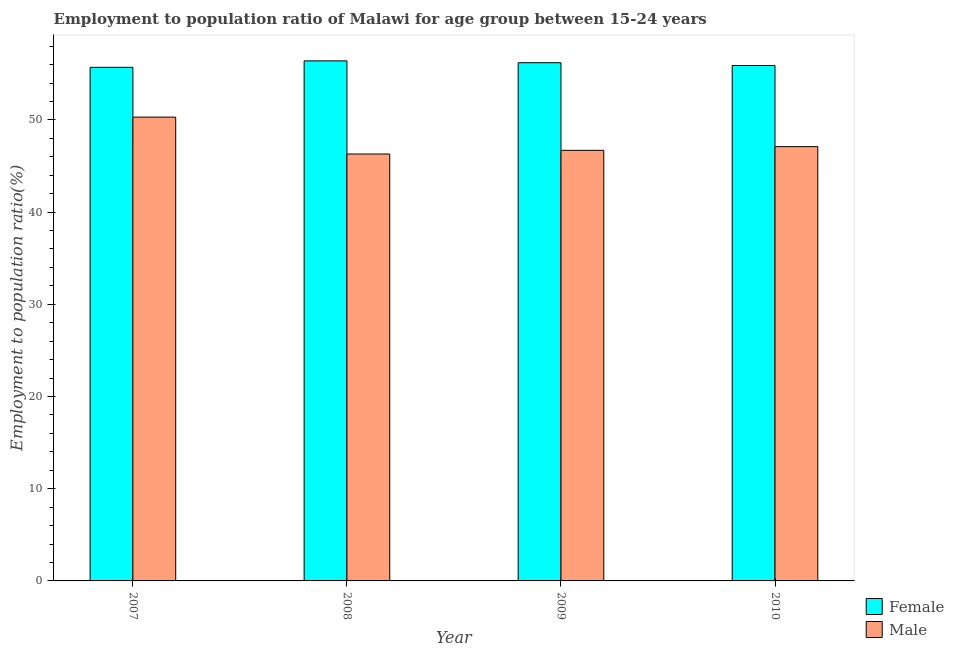How many groups of bars are there?
Provide a succinct answer. 4. Are the number of bars on each tick of the X-axis equal?
Give a very brief answer. Yes. How many bars are there on the 3rd tick from the right?
Offer a very short reply. 2. What is the employment to population ratio(male) in 2009?
Make the answer very short. 46.7. Across all years, what is the maximum employment to population ratio(female)?
Provide a short and direct response. 56.4. Across all years, what is the minimum employment to population ratio(male)?
Make the answer very short. 46.3. In which year was the employment to population ratio(male) maximum?
Offer a very short reply. 2007. What is the total employment to population ratio(female) in the graph?
Make the answer very short. 224.2. What is the difference between the employment to population ratio(male) in 2009 and that in 2010?
Your answer should be compact. -0.4. What is the difference between the employment to population ratio(male) in 2010 and the employment to population ratio(female) in 2007?
Offer a very short reply. -3.2. What is the average employment to population ratio(female) per year?
Your response must be concise. 56.05. In the year 2008, what is the difference between the employment to population ratio(female) and employment to population ratio(male)?
Your answer should be very brief. 0. In how many years, is the employment to population ratio(female) greater than 14 %?
Provide a short and direct response. 4. What is the ratio of the employment to population ratio(male) in 2007 to that in 2009?
Offer a terse response. 1.08. Is the employment to population ratio(male) in 2008 less than that in 2009?
Offer a very short reply. Yes. What is the difference between the highest and the second highest employment to population ratio(male)?
Offer a very short reply. 3.2. What is the difference between the highest and the lowest employment to population ratio(male)?
Give a very brief answer. 4. In how many years, is the employment to population ratio(male) greater than the average employment to population ratio(male) taken over all years?
Keep it short and to the point. 1. What does the 2nd bar from the left in 2009 represents?
Provide a succinct answer. Male. What does the 1st bar from the right in 2007 represents?
Provide a succinct answer. Male. Does the graph contain grids?
Your answer should be compact. No. What is the title of the graph?
Your answer should be compact. Employment to population ratio of Malawi for age group between 15-24 years. What is the label or title of the Y-axis?
Give a very brief answer. Employment to population ratio(%). What is the Employment to population ratio(%) of Female in 2007?
Offer a terse response. 55.7. What is the Employment to population ratio(%) in Male in 2007?
Offer a very short reply. 50.3. What is the Employment to population ratio(%) in Female in 2008?
Give a very brief answer. 56.4. What is the Employment to population ratio(%) of Male in 2008?
Give a very brief answer. 46.3. What is the Employment to population ratio(%) in Female in 2009?
Provide a short and direct response. 56.2. What is the Employment to population ratio(%) in Male in 2009?
Keep it short and to the point. 46.7. What is the Employment to population ratio(%) of Female in 2010?
Your answer should be very brief. 55.9. What is the Employment to population ratio(%) of Male in 2010?
Make the answer very short. 47.1. Across all years, what is the maximum Employment to population ratio(%) in Female?
Provide a succinct answer. 56.4. Across all years, what is the maximum Employment to population ratio(%) in Male?
Your answer should be compact. 50.3. Across all years, what is the minimum Employment to population ratio(%) in Female?
Offer a terse response. 55.7. Across all years, what is the minimum Employment to population ratio(%) of Male?
Offer a very short reply. 46.3. What is the total Employment to population ratio(%) in Female in the graph?
Make the answer very short. 224.2. What is the total Employment to population ratio(%) of Male in the graph?
Provide a short and direct response. 190.4. What is the difference between the Employment to population ratio(%) in Male in 2007 and that in 2008?
Ensure brevity in your answer.  4. What is the difference between the Employment to population ratio(%) in Female in 2007 and that in 2010?
Your answer should be very brief. -0.2. What is the difference between the Employment to population ratio(%) of Male in 2007 and that in 2010?
Give a very brief answer. 3.2. What is the difference between the Employment to population ratio(%) of Male in 2008 and that in 2009?
Make the answer very short. -0.4. What is the difference between the Employment to population ratio(%) of Male in 2008 and that in 2010?
Your answer should be compact. -0.8. What is the difference between the Employment to population ratio(%) of Female in 2009 and that in 2010?
Offer a terse response. 0.3. What is the difference between the Employment to population ratio(%) in Male in 2009 and that in 2010?
Offer a terse response. -0.4. What is the difference between the Employment to population ratio(%) in Female in 2007 and the Employment to population ratio(%) in Male in 2008?
Give a very brief answer. 9.4. What is the difference between the Employment to population ratio(%) of Female in 2007 and the Employment to population ratio(%) of Male in 2010?
Keep it short and to the point. 8.6. What is the difference between the Employment to population ratio(%) of Female in 2008 and the Employment to population ratio(%) of Male in 2009?
Offer a very short reply. 9.7. What is the average Employment to population ratio(%) of Female per year?
Provide a short and direct response. 56.05. What is the average Employment to population ratio(%) in Male per year?
Your answer should be very brief. 47.6. In the year 2009, what is the difference between the Employment to population ratio(%) of Female and Employment to population ratio(%) of Male?
Keep it short and to the point. 9.5. What is the ratio of the Employment to population ratio(%) in Female in 2007 to that in 2008?
Offer a very short reply. 0.99. What is the ratio of the Employment to population ratio(%) in Male in 2007 to that in 2008?
Keep it short and to the point. 1.09. What is the ratio of the Employment to population ratio(%) in Male in 2007 to that in 2009?
Keep it short and to the point. 1.08. What is the ratio of the Employment to population ratio(%) of Female in 2007 to that in 2010?
Your answer should be very brief. 1. What is the ratio of the Employment to population ratio(%) in Male in 2007 to that in 2010?
Offer a terse response. 1.07. What is the ratio of the Employment to population ratio(%) of Male in 2008 to that in 2009?
Your response must be concise. 0.99. What is the ratio of the Employment to population ratio(%) of Female in 2008 to that in 2010?
Your answer should be compact. 1.01. What is the ratio of the Employment to population ratio(%) in Male in 2008 to that in 2010?
Your answer should be very brief. 0.98. What is the ratio of the Employment to population ratio(%) of Female in 2009 to that in 2010?
Give a very brief answer. 1.01. What is the difference between the highest and the second highest Employment to population ratio(%) of Female?
Ensure brevity in your answer.  0.2. What is the difference between the highest and the second highest Employment to population ratio(%) of Male?
Give a very brief answer. 3.2. What is the difference between the highest and the lowest Employment to population ratio(%) in Female?
Offer a terse response. 0.7. What is the difference between the highest and the lowest Employment to population ratio(%) in Male?
Your response must be concise. 4. 